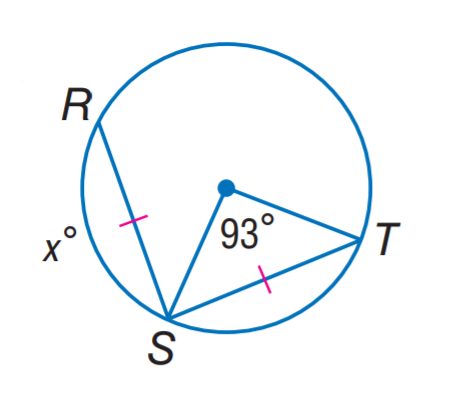Answer the mathemtical geometry problem and directly provide the correct option letter.
Question: Find x.
Choices: A: 46.5 B: 87 C: 93 D: 105 C 